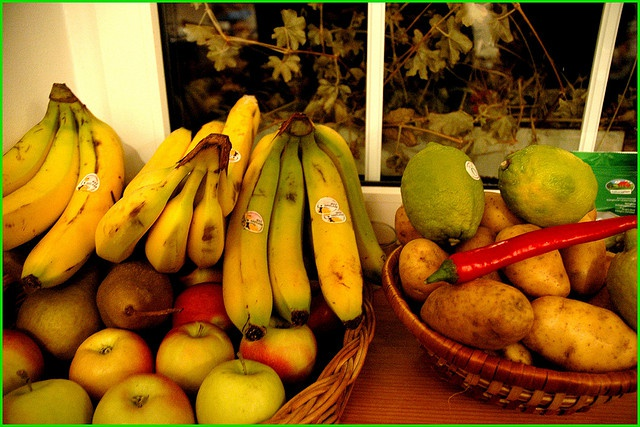Describe the objects in this image and their specific colors. I can see banana in lime, orange, olive, gold, and maroon tones, banana in lime, orange, olive, and black tones, apple in lime, orange, olive, and maroon tones, dining table in lime, maroon, and brown tones, and bowl in lime, maroon, black, and brown tones in this image. 